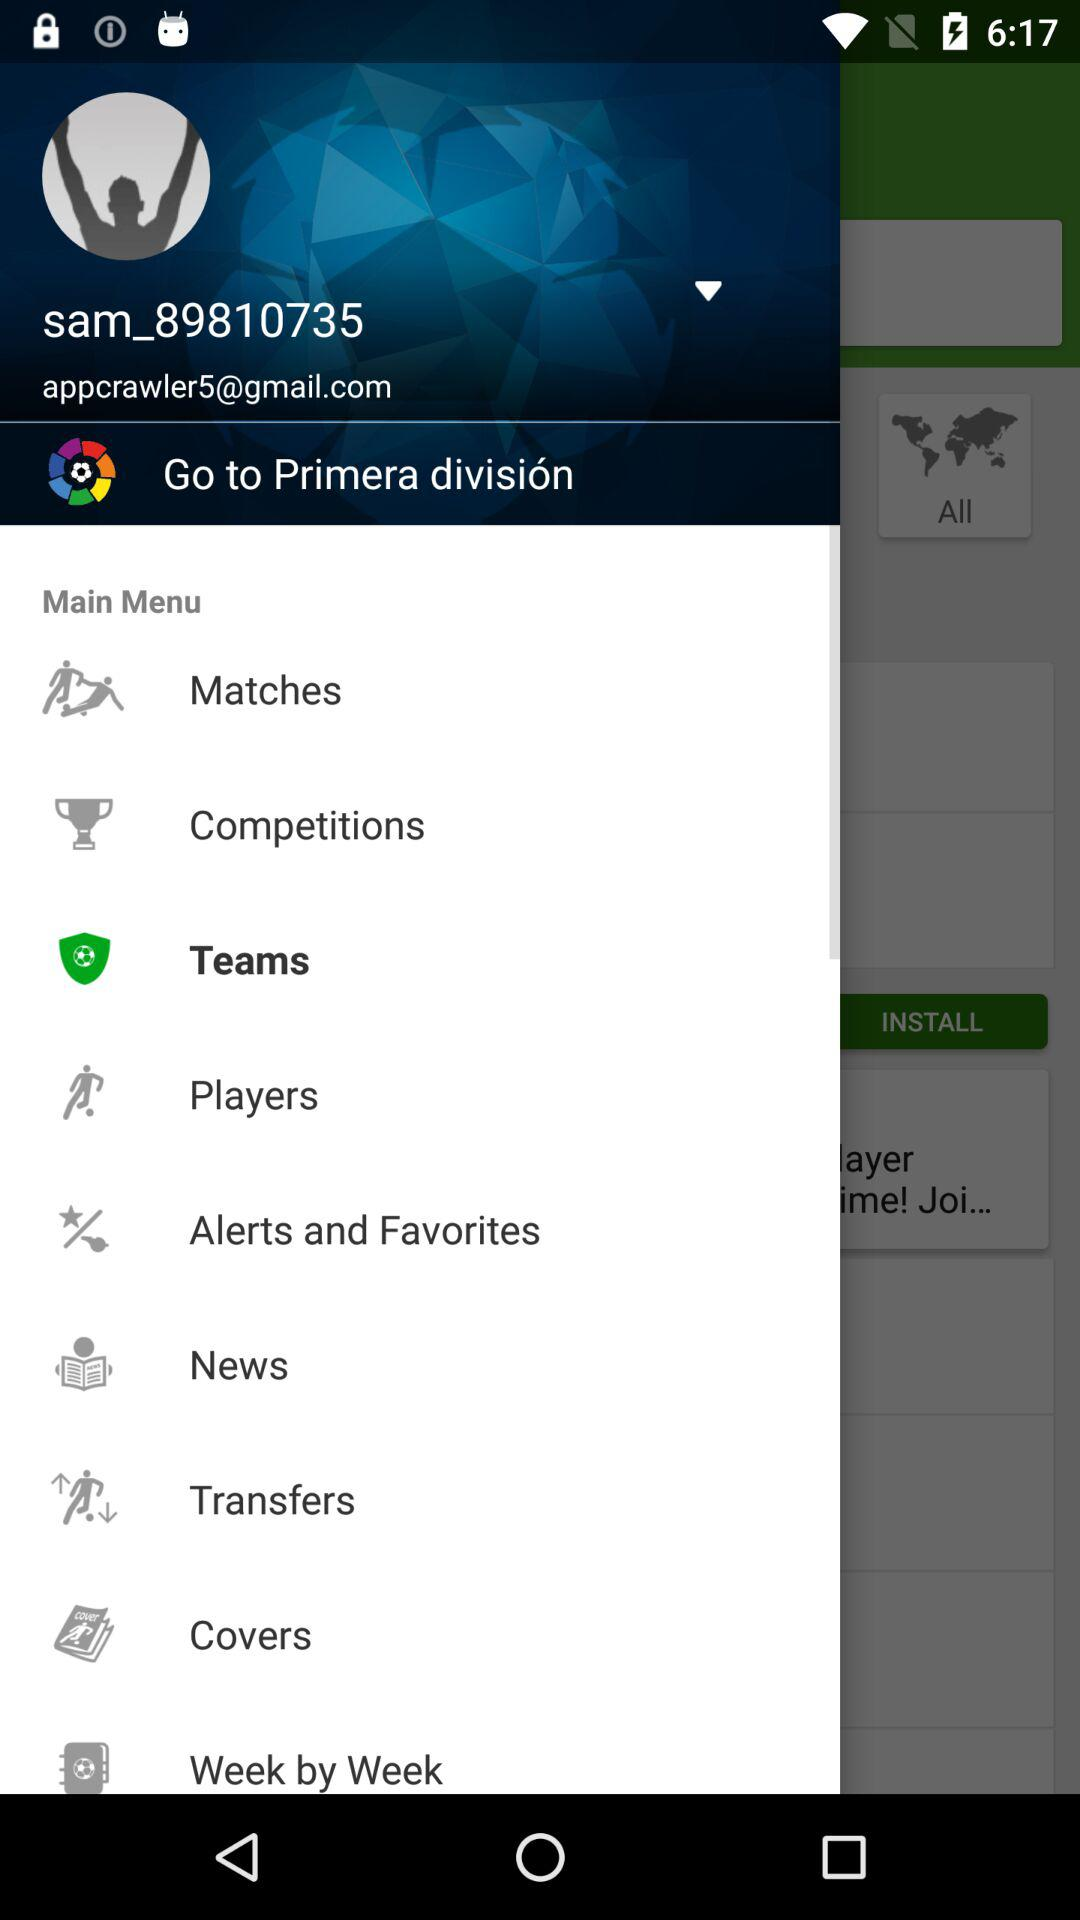What is the email address? The email address is appcrawler5@gmail.com. 